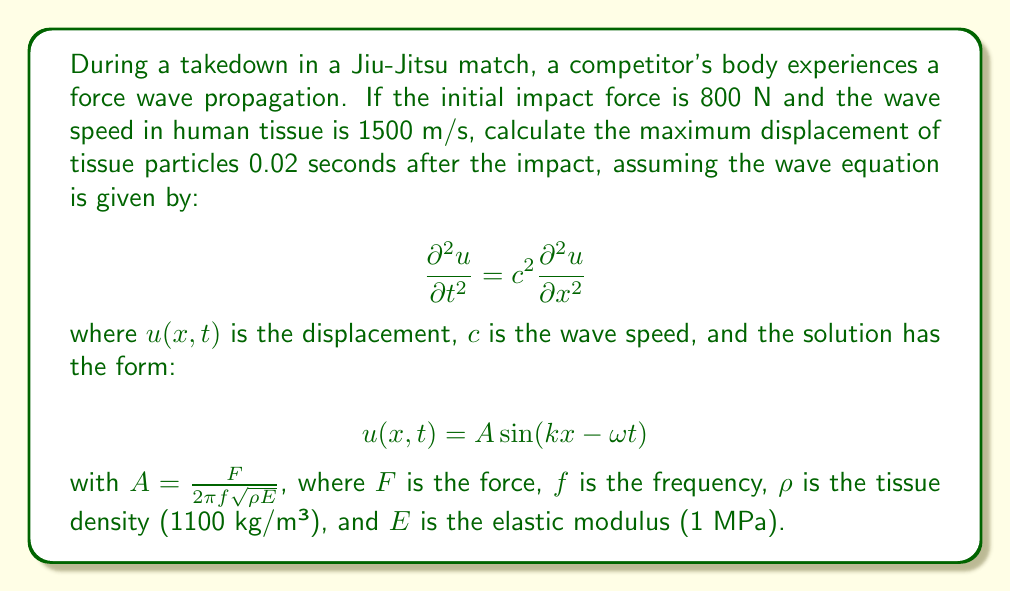Help me with this question. 1) First, we need to determine the wave number $k$ and angular frequency $\omega$:
   $$c = \frac{\omega}{k} = 1500 \text{ m/s}$$

2) We can assume the wavelength is much larger than the body dimensions, so let's use $\lambda = 10 \text{ m}$:
   $$k = \frac{2\pi}{\lambda} = \frac{2\pi}{10} = 0.628 \text{ m}^{-1}$$

3) Now we can calculate $\omega$:
   $$\omega = ck = 1500 \cdot 0.628 = 942 \text{ rad/s}$$

4) The frequency $f$ is:
   $$f = \frac{\omega}{2\pi} = \frac{942}{2\pi} = 150 \text{ Hz}$$

5) Calculate the amplitude $A$:
   $$A = \frac{F}{2\pi f \sqrt{\rho E}} = \frac{800}{2\pi \cdot 150 \cdot \sqrt{1100 \cdot 10^6}} = 1.02 \cdot 10^{-3} \text{ m}$$

6) The displacement at any point and time is given by:
   $$u(x,t) = 1.02 \cdot 10^{-3} \sin(0.628x - 942t)$$

7) The maximum displacement occurs when $\sin(0.628x - 942t) = 1$, so:
   $$u_{\text{max}} = 1.02 \cdot 10^{-3} \text{ m} = 1.02 \text{ mm}$$

This maximum displacement will occur periodically in space and time.
Answer: 1.02 mm 